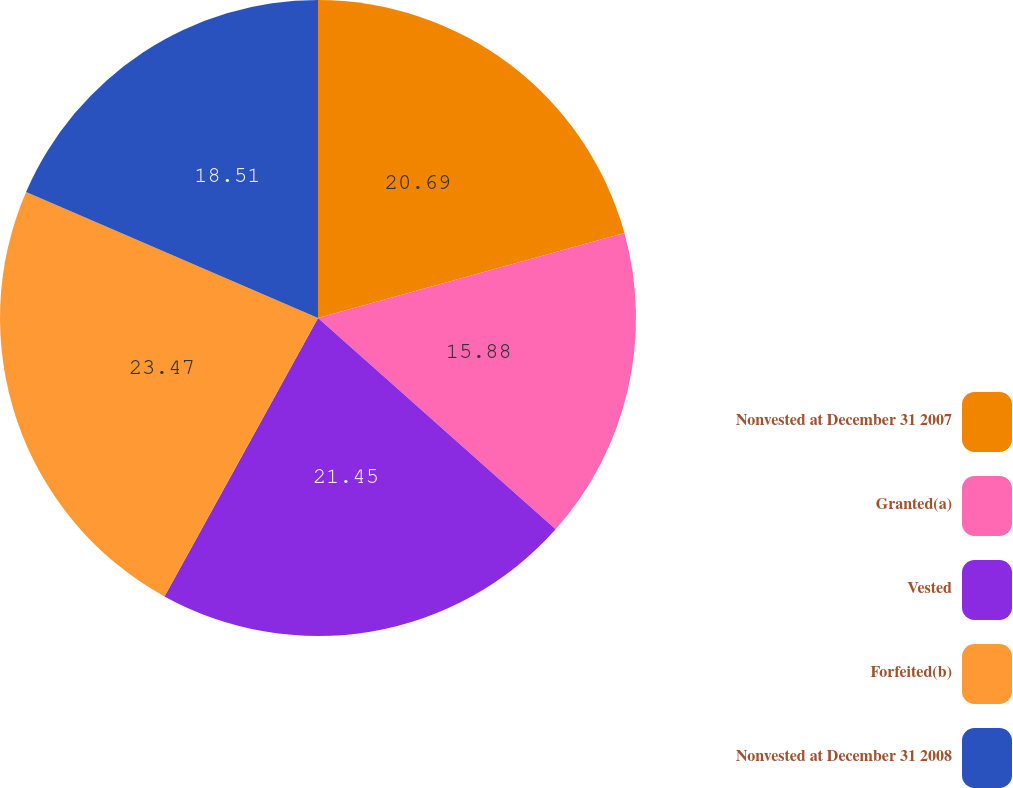Convert chart. <chart><loc_0><loc_0><loc_500><loc_500><pie_chart><fcel>Nonvested at December 31 2007<fcel>Granted(a)<fcel>Vested<fcel>Forfeited(b)<fcel>Nonvested at December 31 2008<nl><fcel>20.69%<fcel>15.88%<fcel>21.45%<fcel>23.47%<fcel>18.51%<nl></chart> 